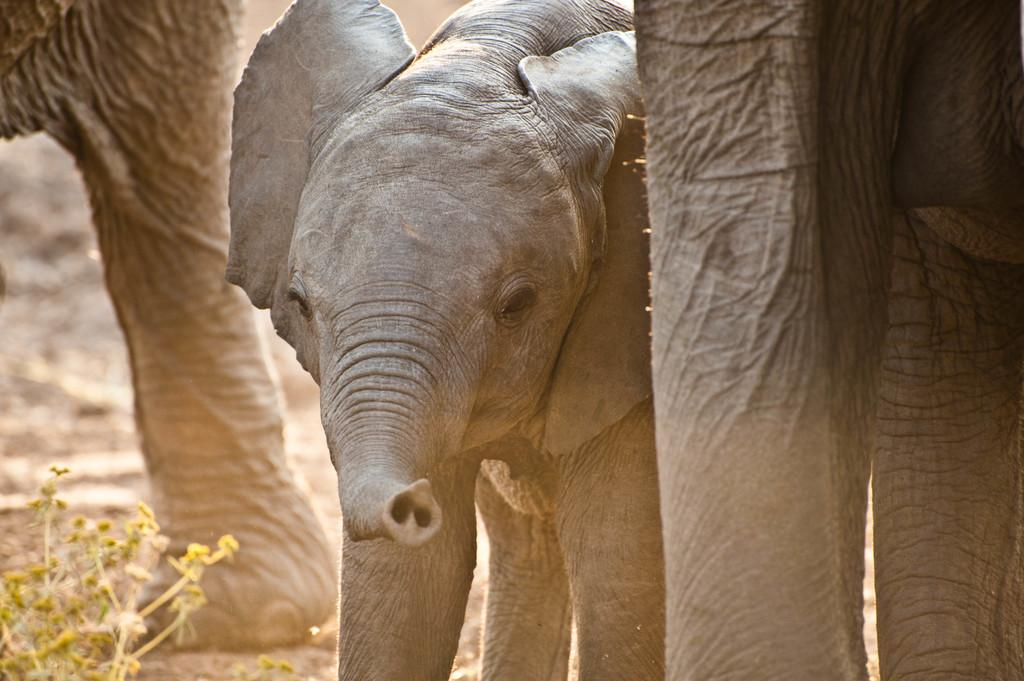What type of animal is in the picture? There is a baby elephant in the picture. What is the baby elephant doing? The baby elephant is standing. Are there any other elephants in the picture? Yes, there is another elephant near the baby elephant. What else can be seen in the picture? There is a plant in the picture. What type of tin can be seen in the picture? There is no tin present in the picture; it features a baby elephant and another elephant, along with a plant. How many grapes are visible in the picture? There are no grapes present in the picture. 